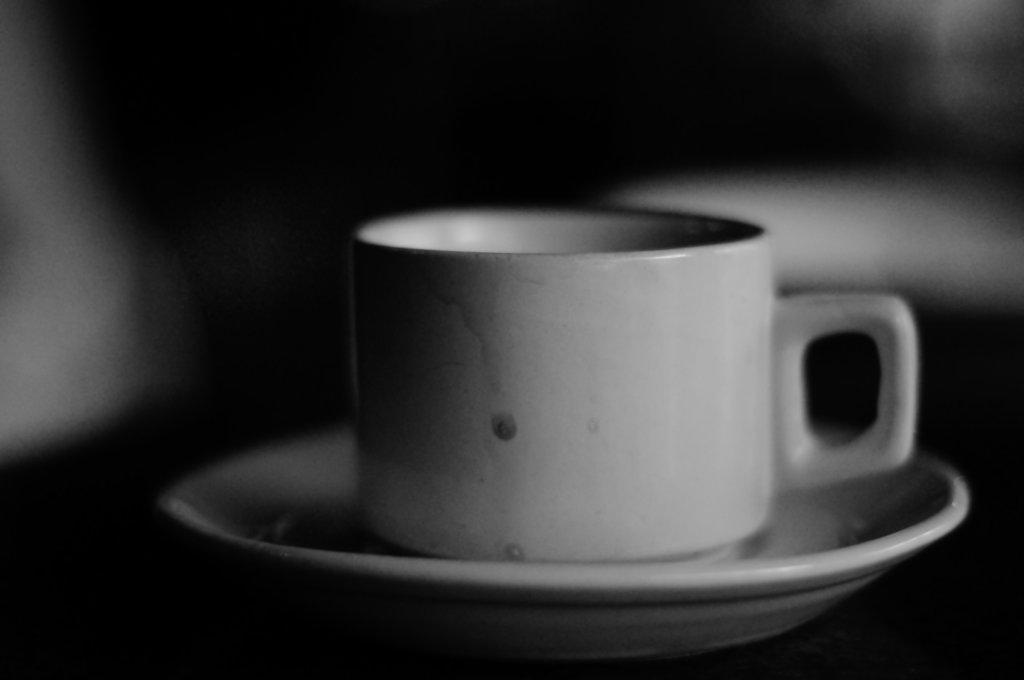Could you give a brief overview of what you see in this image? This is a black and white image and here we can see a cup on the saucer. 